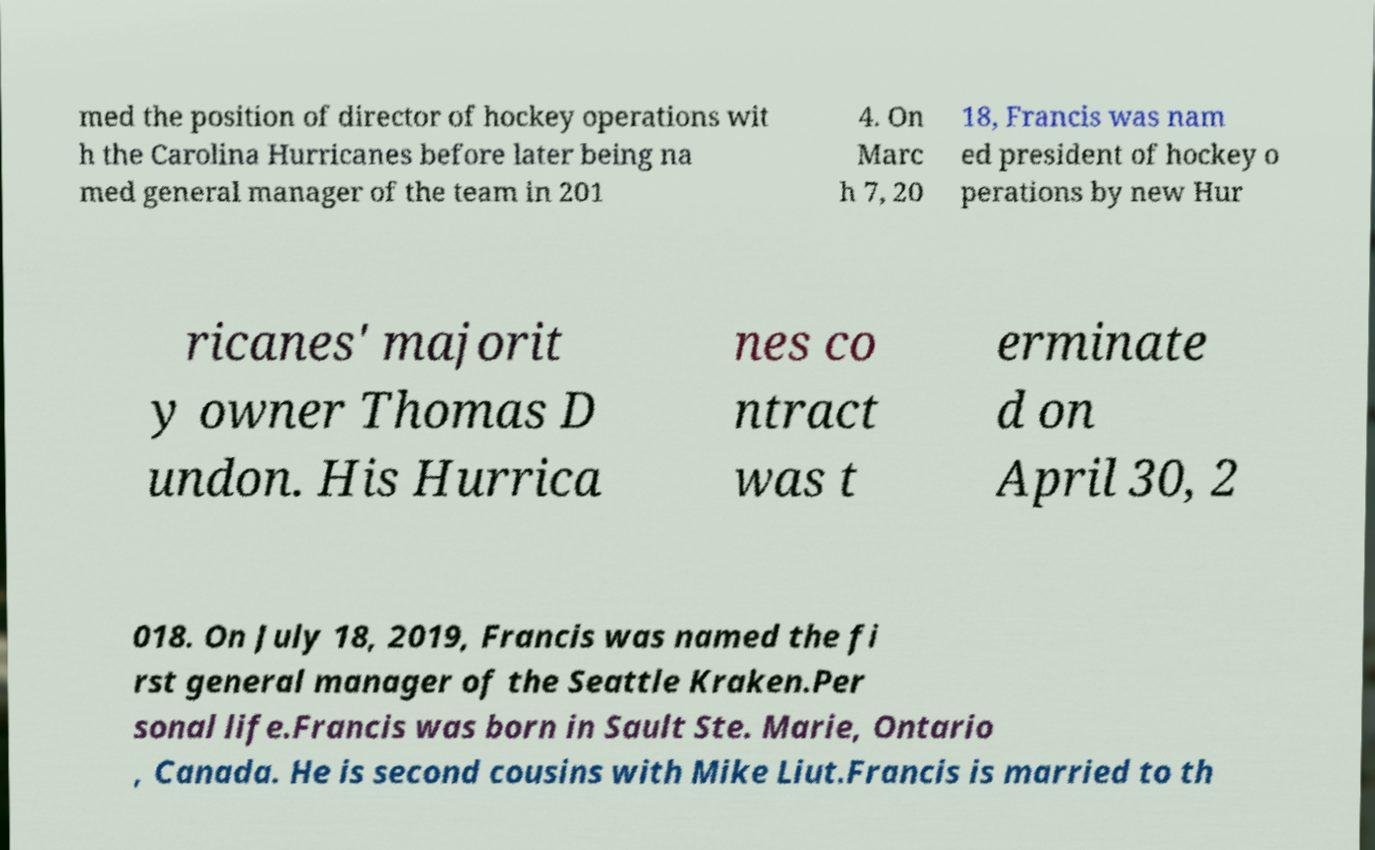Can you accurately transcribe the text from the provided image for me? med the position of director of hockey operations wit h the Carolina Hurricanes before later being na med general manager of the team in 201 4. On Marc h 7, 20 18, Francis was nam ed president of hockey o perations by new Hur ricanes' majorit y owner Thomas D undon. His Hurrica nes co ntract was t erminate d on April 30, 2 018. On July 18, 2019, Francis was named the fi rst general manager of the Seattle Kraken.Per sonal life.Francis was born in Sault Ste. Marie, Ontario , Canada. He is second cousins with Mike Liut.Francis is married to th 